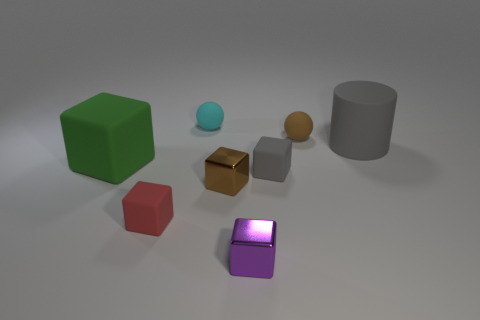Can you tell me how many objects are in this image, and if they are resting on some surface? There are six objects in this image, with each object resting on what seems to be a flat, smooth surface that has a neutral tone, possibly representing a table or the ground in an uncluttered space. 